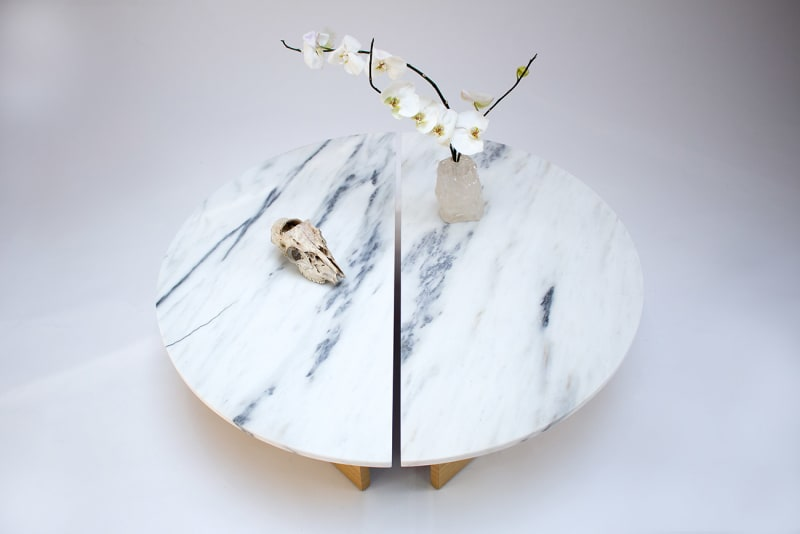How do the individual items on the table complement each other? The smooth, veined surface of the marble table highlights the purity and solidity of the crystal quartz and contrasts with the delicate orchid's transient blooms. The skull, while a stark symbol of mortality, also echoes the table's pale tones, tying the elements together visually and thematically. The differing textures and meanings behind each piece come together to create a balanced tableau, inviting contemplation on the interplay between life, art, and time. 